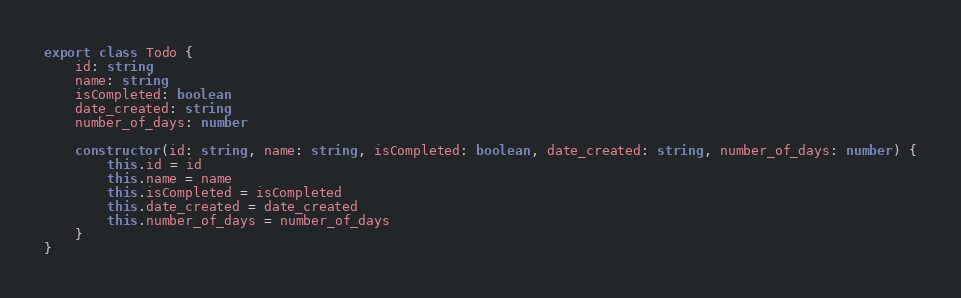Convert code to text. <code><loc_0><loc_0><loc_500><loc_500><_TypeScript_>export class Todo {
    id: string
    name: string
    isCompleted: boolean
    date_created: string
    number_of_days: number

    constructor(id: string, name: string, isCompleted: boolean, date_created: string, number_of_days: number) {
        this.id = id
        this.name = name
        this.isCompleted = isCompleted
        this.date_created = date_created
        this.number_of_days = number_of_days
    }
}
</code> 